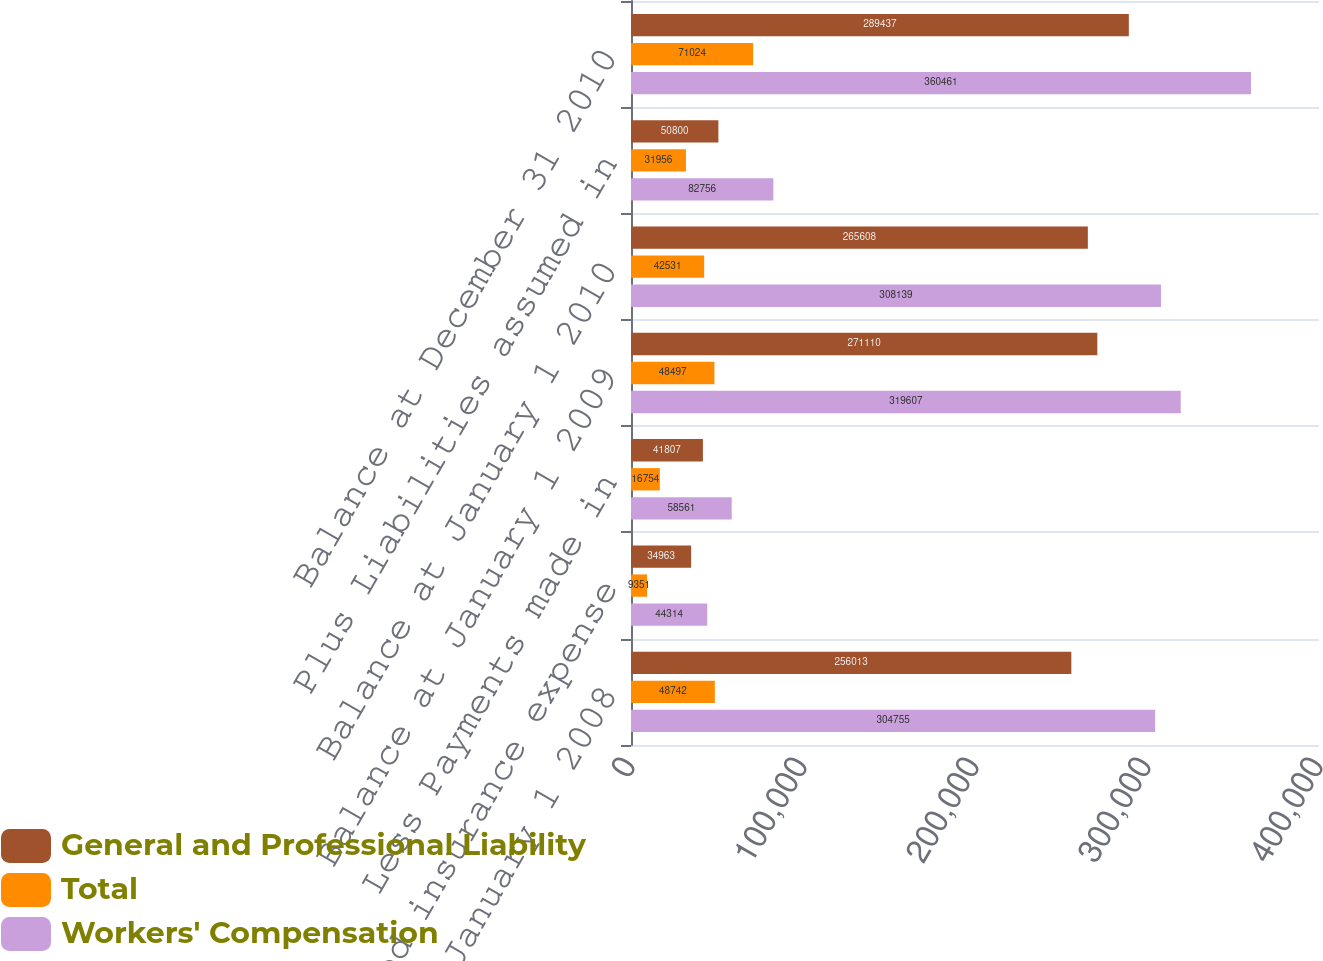Convert chart to OTSL. <chart><loc_0><loc_0><loc_500><loc_500><stacked_bar_chart><ecel><fcel>Balance at January 1 2008<fcel>Plus accrued insurance expense<fcel>Less Payments made in<fcel>Balance at January 1 2009<fcel>Balance at January 1 2010<fcel>Plus Liabilities assumed in<fcel>Balance at December 31 2010<nl><fcel>General and Professional Liability<fcel>256013<fcel>34963<fcel>41807<fcel>271110<fcel>265608<fcel>50800<fcel>289437<nl><fcel>Total<fcel>48742<fcel>9351<fcel>16754<fcel>48497<fcel>42531<fcel>31956<fcel>71024<nl><fcel>Workers' Compensation<fcel>304755<fcel>44314<fcel>58561<fcel>319607<fcel>308139<fcel>82756<fcel>360461<nl></chart> 